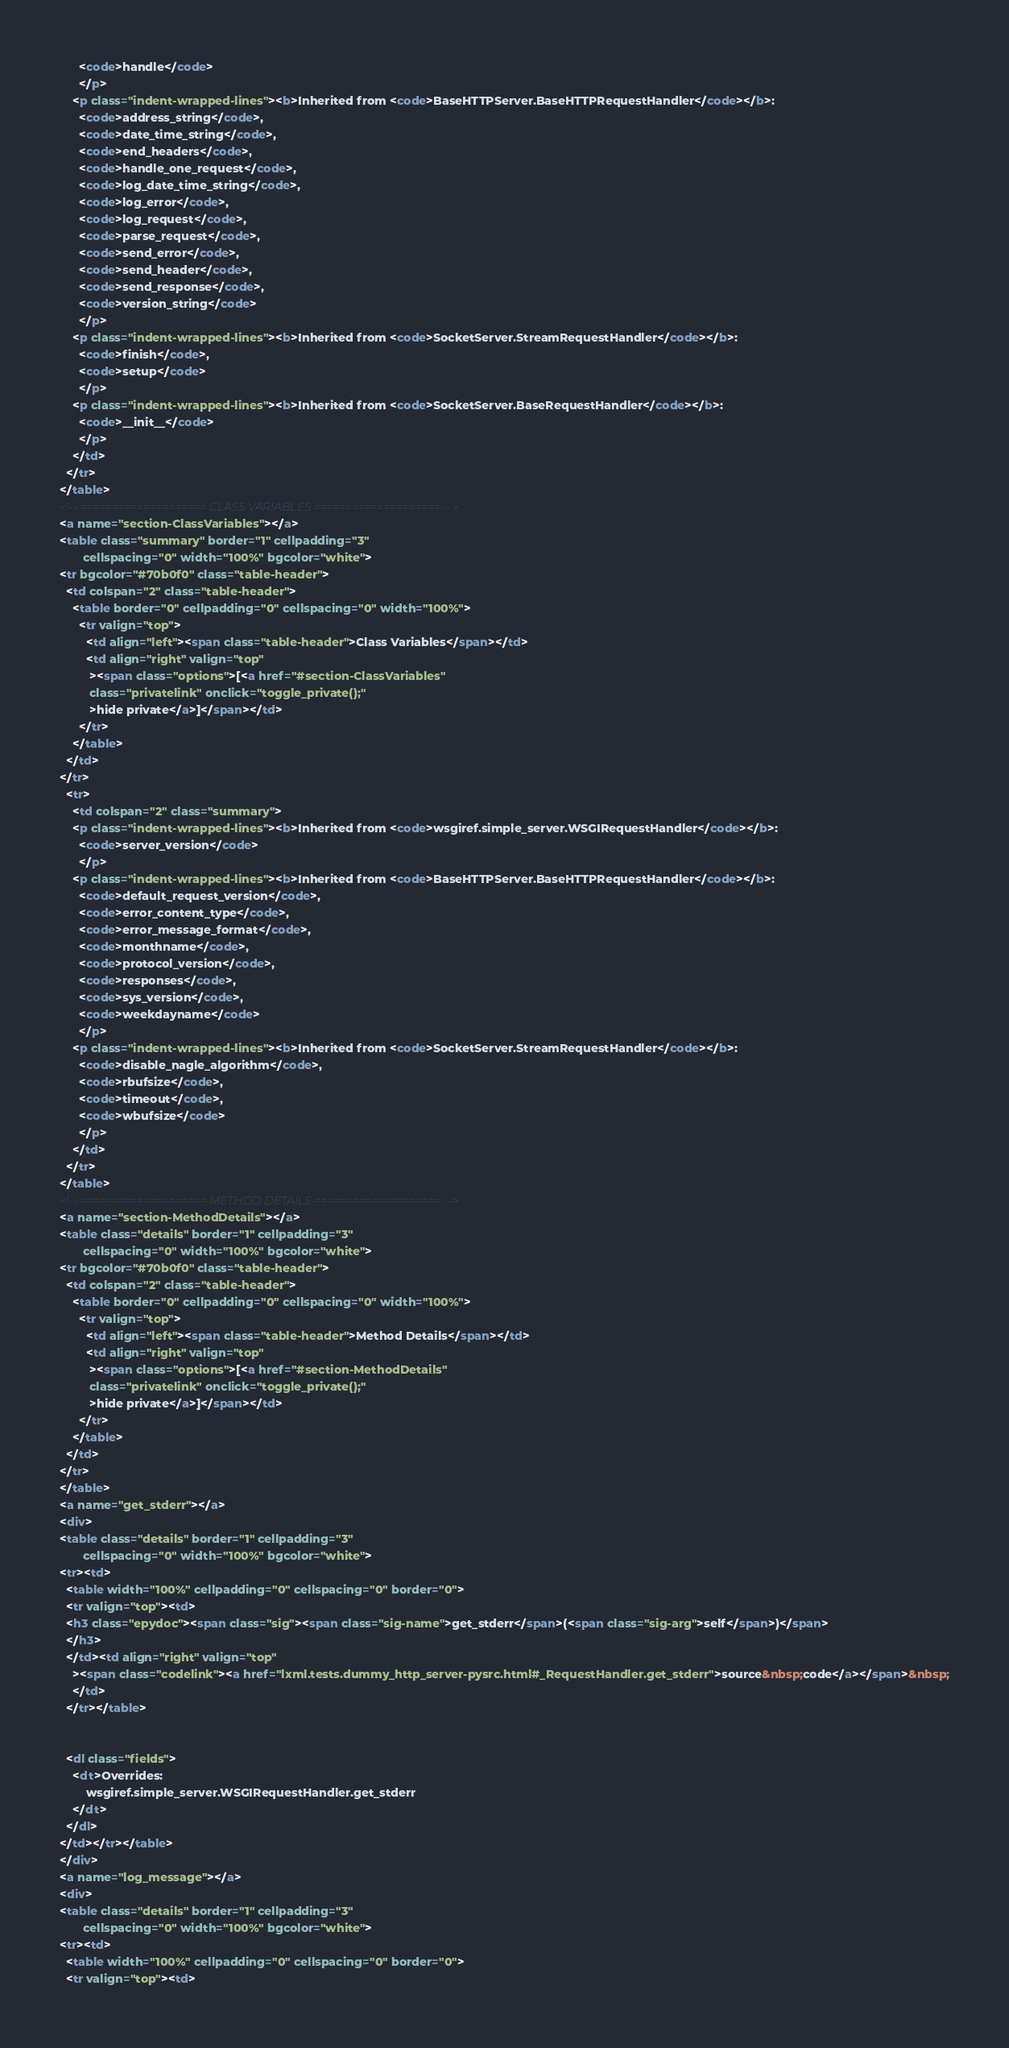<code> <loc_0><loc_0><loc_500><loc_500><_HTML_>      <code>handle</code>
      </p>
    <p class="indent-wrapped-lines"><b>Inherited from <code>BaseHTTPServer.BaseHTTPRequestHandler</code></b>:
      <code>address_string</code>,
      <code>date_time_string</code>,
      <code>end_headers</code>,
      <code>handle_one_request</code>,
      <code>log_date_time_string</code>,
      <code>log_error</code>,
      <code>log_request</code>,
      <code>parse_request</code>,
      <code>send_error</code>,
      <code>send_header</code>,
      <code>send_response</code>,
      <code>version_string</code>
      </p>
    <p class="indent-wrapped-lines"><b>Inherited from <code>SocketServer.StreamRequestHandler</code></b>:
      <code>finish</code>,
      <code>setup</code>
      </p>
    <p class="indent-wrapped-lines"><b>Inherited from <code>SocketServer.BaseRequestHandler</code></b>:
      <code>__init__</code>
      </p>
    </td>
  </tr>
</table>
<!-- ==================== CLASS VARIABLES ==================== -->
<a name="section-ClassVariables"></a>
<table class="summary" border="1" cellpadding="3"
       cellspacing="0" width="100%" bgcolor="white">
<tr bgcolor="#70b0f0" class="table-header">
  <td colspan="2" class="table-header">
    <table border="0" cellpadding="0" cellspacing="0" width="100%">
      <tr valign="top">
        <td align="left"><span class="table-header">Class Variables</span></td>
        <td align="right" valign="top"
         ><span class="options">[<a href="#section-ClassVariables"
         class="privatelink" onclick="toggle_private();"
         >hide private</a>]</span></td>
      </tr>
    </table>
  </td>
</tr>
  <tr>
    <td colspan="2" class="summary">
    <p class="indent-wrapped-lines"><b>Inherited from <code>wsgiref.simple_server.WSGIRequestHandler</code></b>:
      <code>server_version</code>
      </p>
    <p class="indent-wrapped-lines"><b>Inherited from <code>BaseHTTPServer.BaseHTTPRequestHandler</code></b>:
      <code>default_request_version</code>,
      <code>error_content_type</code>,
      <code>error_message_format</code>,
      <code>monthname</code>,
      <code>protocol_version</code>,
      <code>responses</code>,
      <code>sys_version</code>,
      <code>weekdayname</code>
      </p>
    <p class="indent-wrapped-lines"><b>Inherited from <code>SocketServer.StreamRequestHandler</code></b>:
      <code>disable_nagle_algorithm</code>,
      <code>rbufsize</code>,
      <code>timeout</code>,
      <code>wbufsize</code>
      </p>
    </td>
  </tr>
</table>
<!-- ==================== METHOD DETAILS ==================== -->
<a name="section-MethodDetails"></a>
<table class="details" border="1" cellpadding="3"
       cellspacing="0" width="100%" bgcolor="white">
<tr bgcolor="#70b0f0" class="table-header">
  <td colspan="2" class="table-header">
    <table border="0" cellpadding="0" cellspacing="0" width="100%">
      <tr valign="top">
        <td align="left"><span class="table-header">Method Details</span></td>
        <td align="right" valign="top"
         ><span class="options">[<a href="#section-MethodDetails"
         class="privatelink" onclick="toggle_private();"
         >hide private</a>]</span></td>
      </tr>
    </table>
  </td>
</tr>
</table>
<a name="get_stderr"></a>
<div>
<table class="details" border="1" cellpadding="3"
       cellspacing="0" width="100%" bgcolor="white">
<tr><td>
  <table width="100%" cellpadding="0" cellspacing="0" border="0">
  <tr valign="top"><td>
  <h3 class="epydoc"><span class="sig"><span class="sig-name">get_stderr</span>(<span class="sig-arg">self</span>)</span>
  </h3>
  </td><td align="right" valign="top"
    ><span class="codelink"><a href="lxml.tests.dummy_http_server-pysrc.html#_RequestHandler.get_stderr">source&nbsp;code</a></span>&nbsp;
    </td>
  </tr></table>
  
  
  <dl class="fields">
    <dt>Overrides:
        wsgiref.simple_server.WSGIRequestHandler.get_stderr
    </dt>
  </dl>
</td></tr></table>
</div>
<a name="log_message"></a>
<div>
<table class="details" border="1" cellpadding="3"
       cellspacing="0" width="100%" bgcolor="white">
<tr><td>
  <table width="100%" cellpadding="0" cellspacing="0" border="0">
  <tr valign="top"><td></code> 